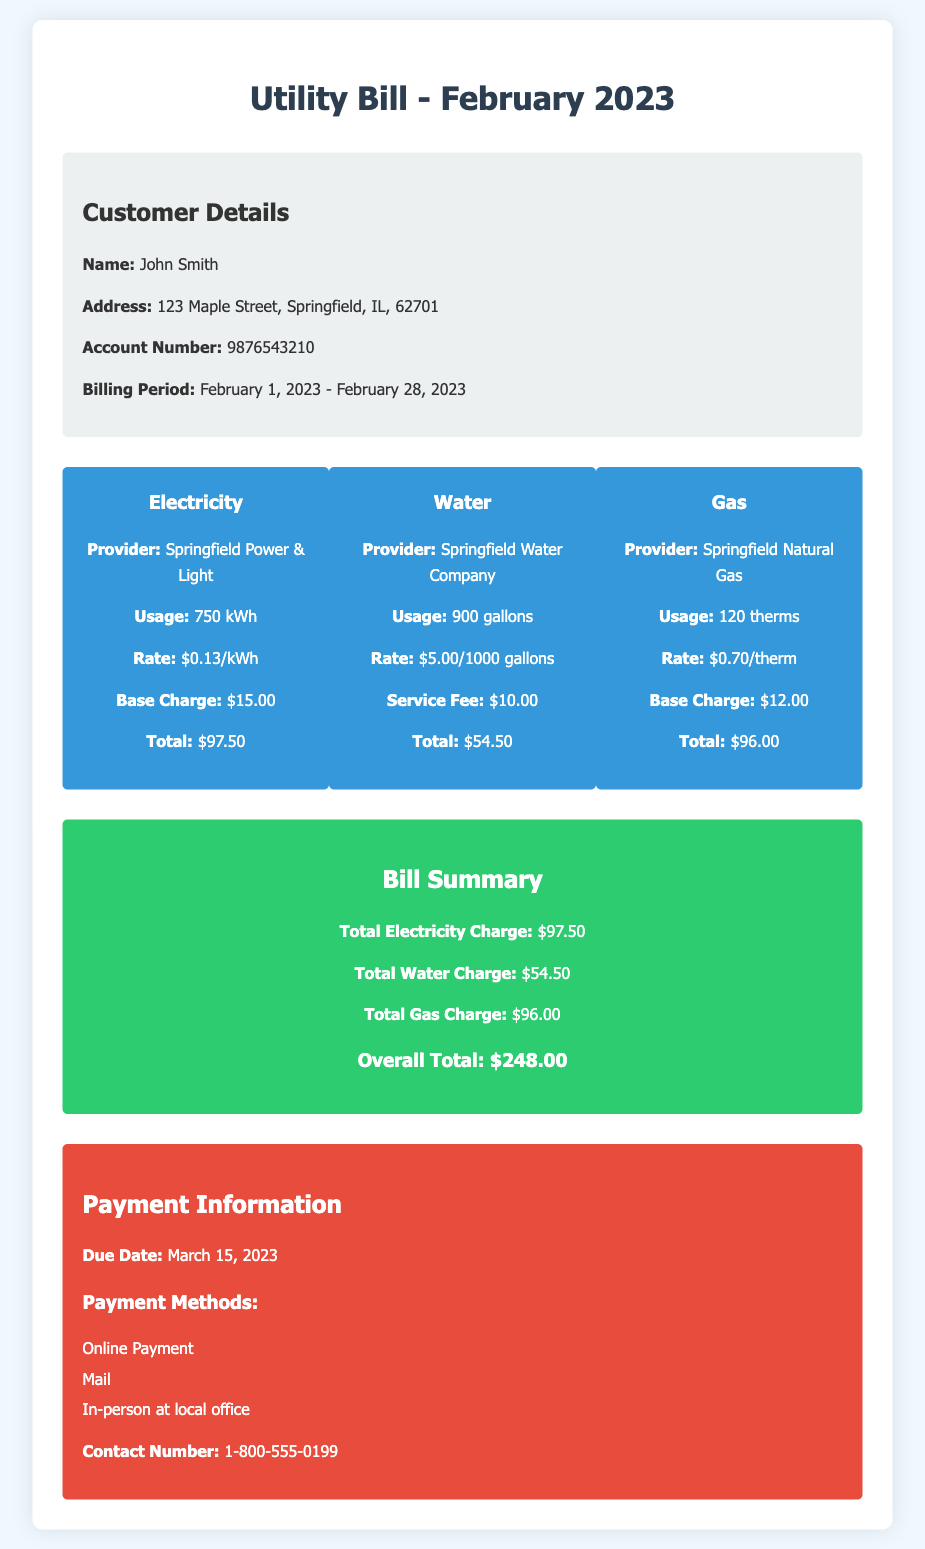What is the billing period? The billing period is specified in the document as February 1, 2023 to February 28, 2023.
Answer: February 1, 2023 - February 28, 2023 Who is the electricity provider? The provider for electricity is mentioned in the bill under the electricity charges section.
Answer: Springfield Power & Light How much was the total gas charge? The total gas charge is calculated and presented in the summary of the bill.
Answer: $96.00 What is the total overall amount due? The overall total is calculated as the sum of all utility charges and is noted in the summary.
Answer: $248.00 What is the due date for the payment? The due date for payment is explicitly indicated in the payment information section of the bill.
Answer: March 15, 2023 How much was paid for water usage? The total for water is detailed in the summary, which combines the rate, usage, and service fee.
Answer: $54.50 What is the service fee for water? The service fee is a specific component of the water charge, mentioned in the water section of the bill.
Answer: $10.00 How many kilowatt-hours were used for electricity? The usage of electricity is provided in the electricity charge section of the document.
Answer: 750 kWh What payment methods are available? The payment methods are listed in the payment information section of the bill.
Answer: Online Payment, Mail, In-person at local office 